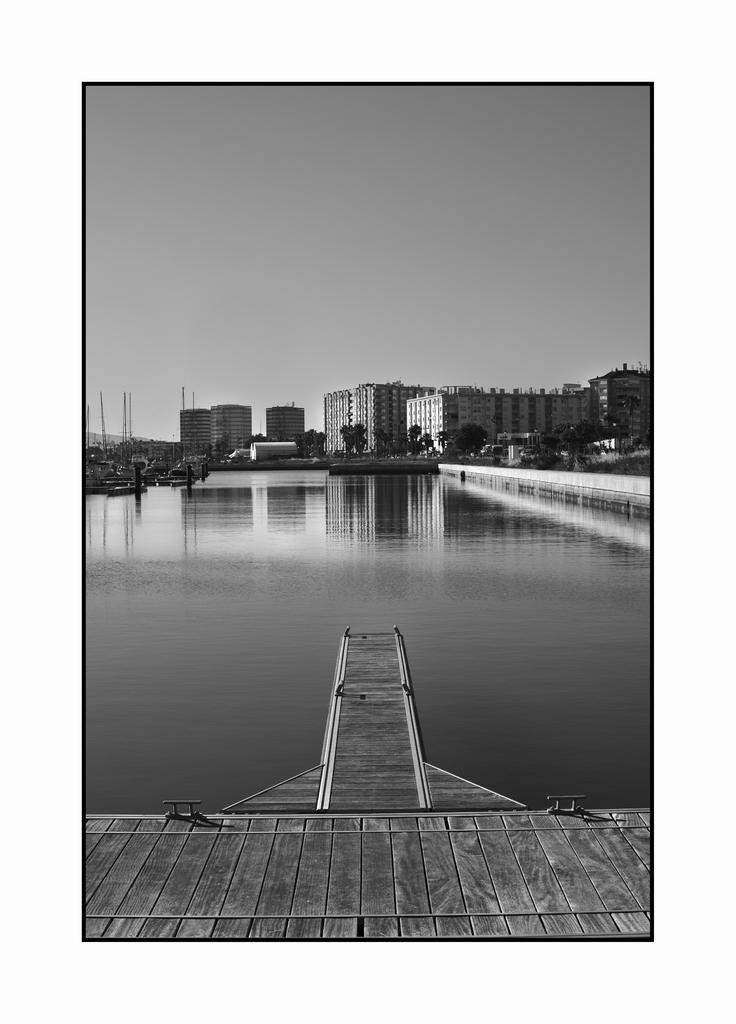What type of structure is present in the image? There is a wooden bridge in the image. What can be seen beneath the bridge? Water is visible in the image. What is visible in the distance behind the bridge? There are buildings and trees in the background of the image. What is visible at the top of the image? The sky is clear and visible at the top of the image. What type of thread is being used to stitch the wound on the wooden bridge in the image? There is no wound or thread present in the image; it features a wooden bridge, water, buildings, trees, and a clear sky. 